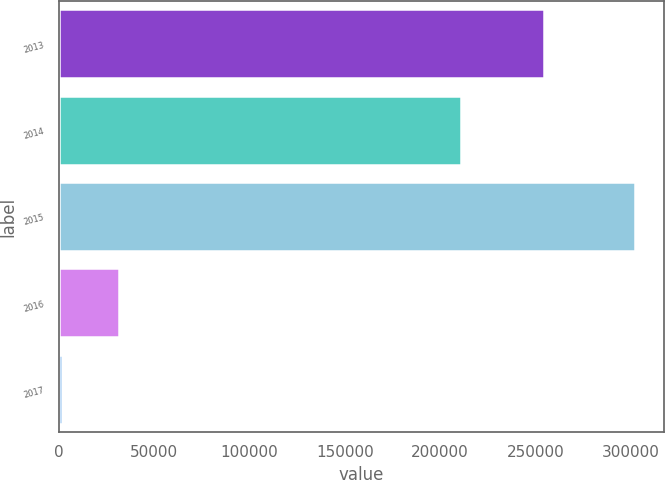Convert chart to OTSL. <chart><loc_0><loc_0><loc_500><loc_500><bar_chart><fcel>2013<fcel>2014<fcel>2015<fcel>2016<fcel>2017<nl><fcel>254650<fcel>210799<fcel>302135<fcel>31839.8<fcel>1807<nl></chart> 